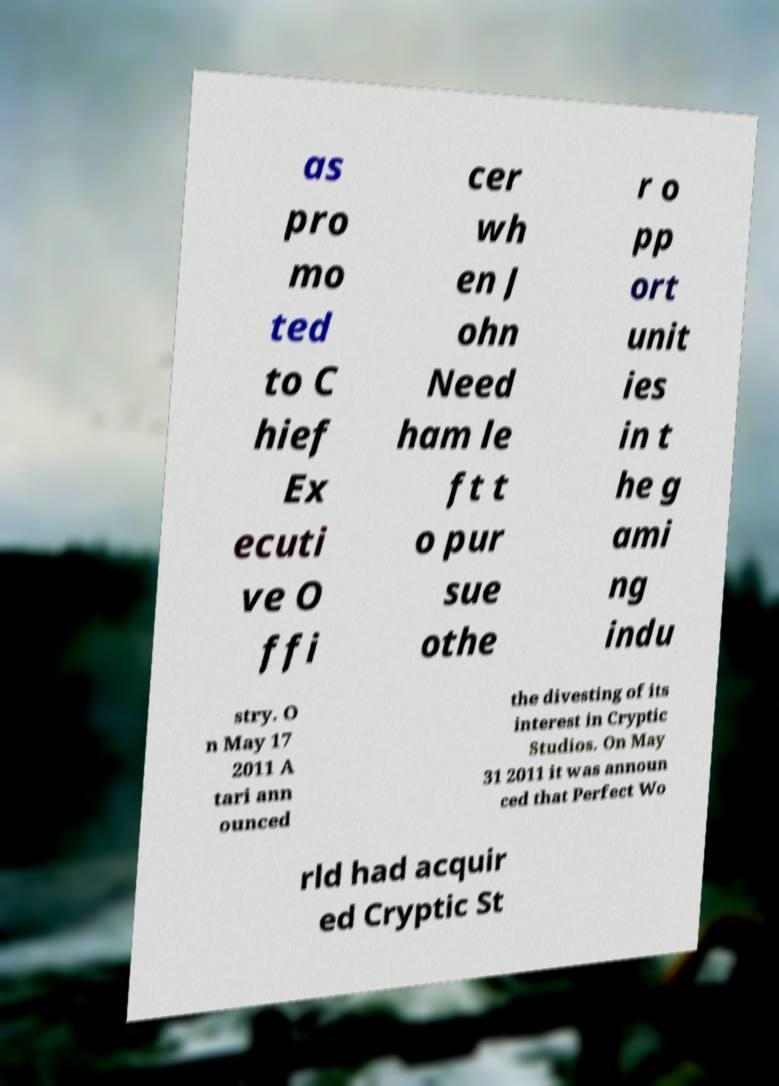Could you extract and type out the text from this image? as pro mo ted to C hief Ex ecuti ve O ffi cer wh en J ohn Need ham le ft t o pur sue othe r o pp ort unit ies in t he g ami ng indu stry. O n May 17 2011 A tari ann ounced the divesting of its interest in Cryptic Studios. On May 31 2011 it was announ ced that Perfect Wo rld had acquir ed Cryptic St 